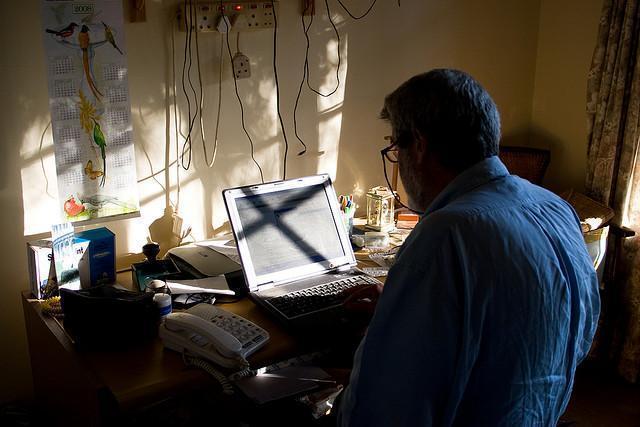What is the man using the computer to do?
Select the correct answer and articulate reasoning with the following format: 'Answer: answer
Rationale: rationale.'
Options: Game, watch movie, film, type. Answer: type.
Rationale: The man has fingers on the keyboard. 